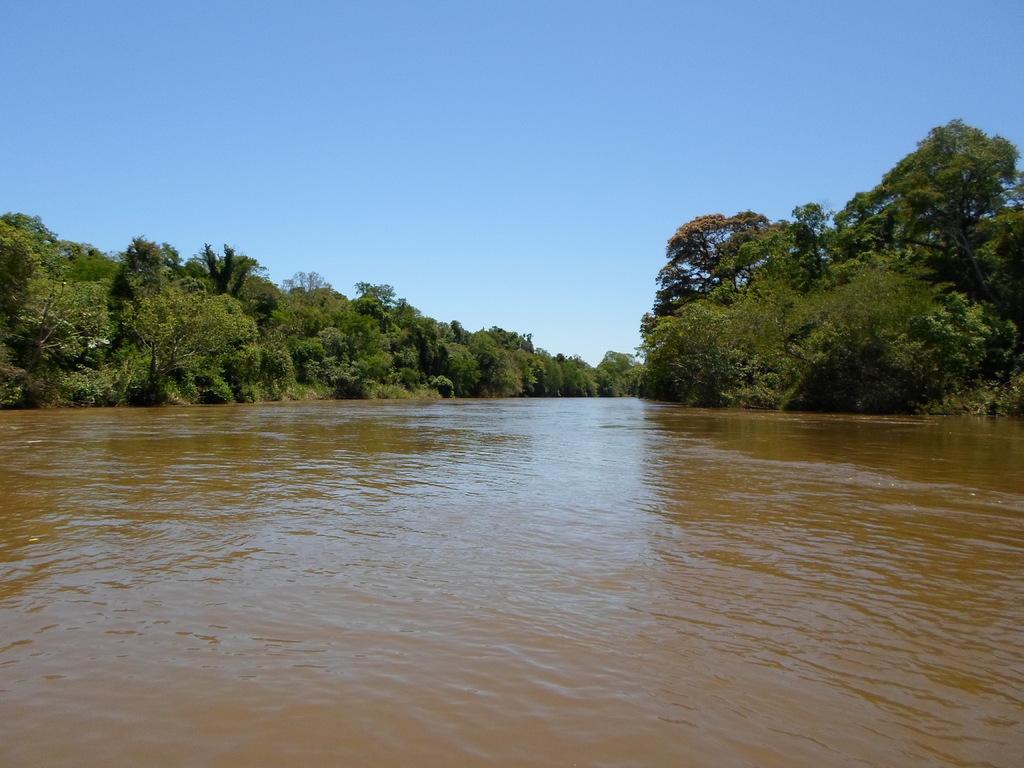Please provide a concise description of this image. In the picture we can see the water surface around it, we can see, full of the trees and the sky. 